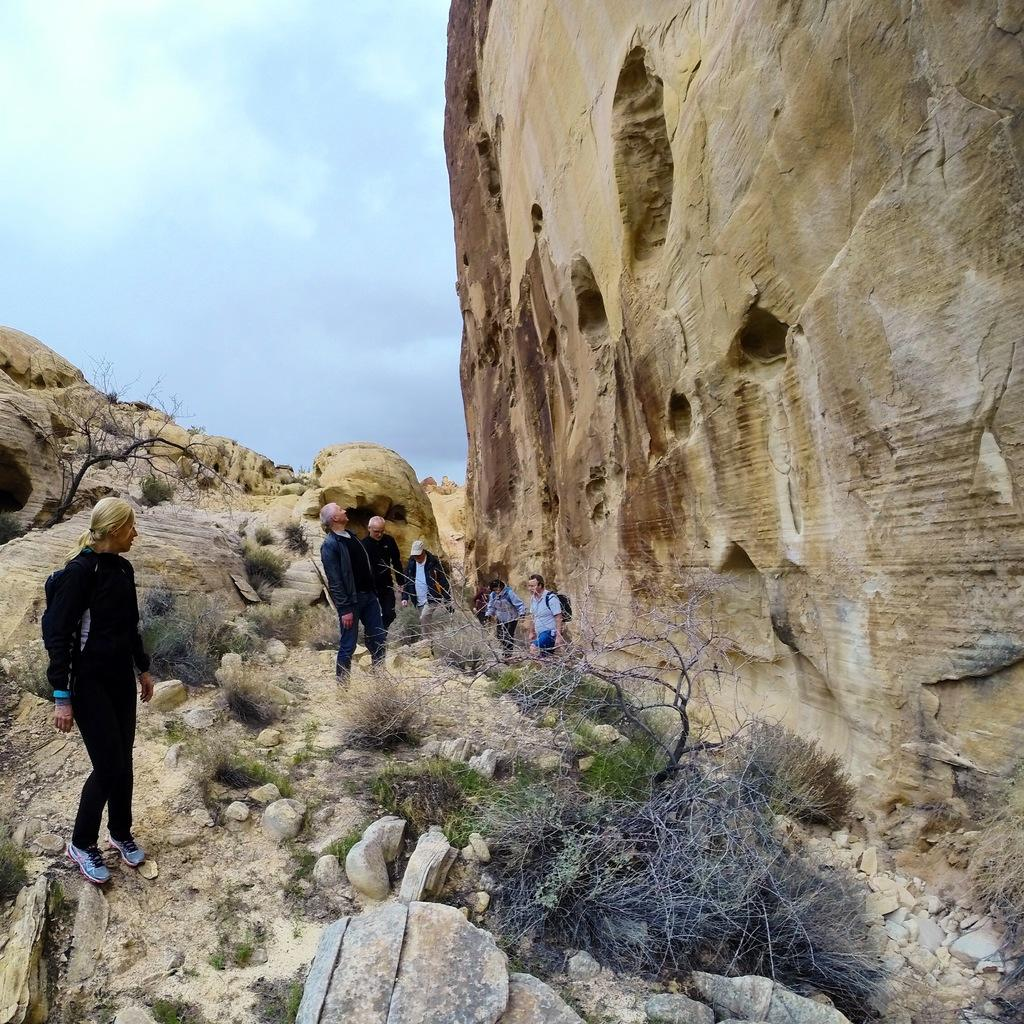What type of natural elements can be seen in the image? There are rocks and grass in the image. Are there any living beings present in the image? Yes, there are people in the image. What part of the natural environment is visible in the image? The sky is visible in the image. What type of mailbox can be seen in the image? There is no mailbox present in the image. How many stars can be seen in the image? There are no stars visible in the image; only the sky is visible. 